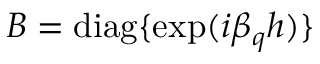<formula> <loc_0><loc_0><loc_500><loc_500>B = d i a g \{ \exp ( i \beta _ { q } h ) \}</formula> 